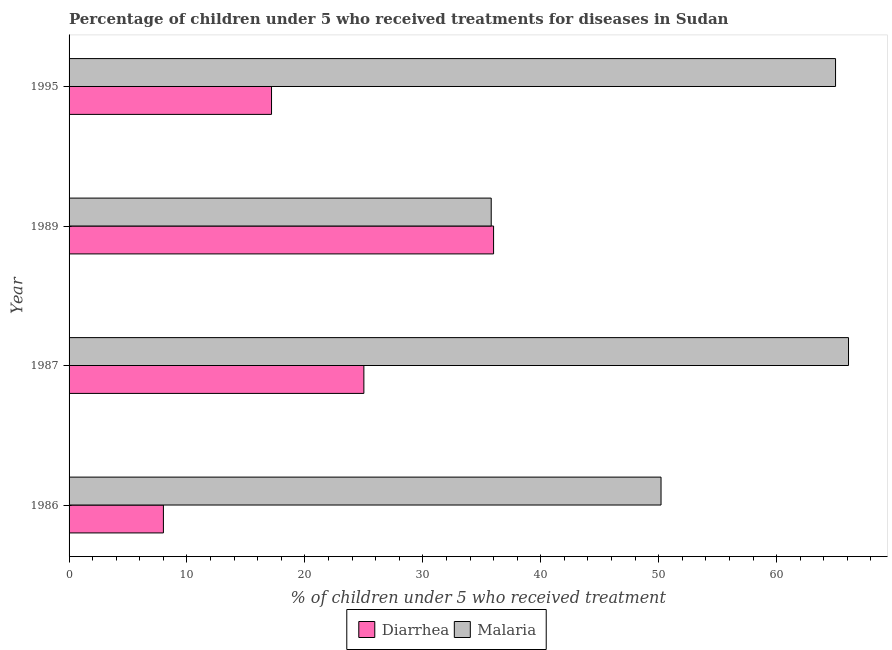How many different coloured bars are there?
Give a very brief answer. 2. What is the label of the 2nd group of bars from the top?
Your response must be concise. 1989. In which year was the percentage of children who received treatment for malaria maximum?
Offer a terse response. 1987. In which year was the percentage of children who received treatment for malaria minimum?
Make the answer very short. 1989. What is the total percentage of children who received treatment for diarrhoea in the graph?
Keep it short and to the point. 86.17. What is the difference between the percentage of children who received treatment for diarrhoea in 1989 and that in 1995?
Give a very brief answer. 18.83. What is the difference between the percentage of children who received treatment for diarrhoea in 1987 and the percentage of children who received treatment for malaria in 1989?
Make the answer very short. -10.8. What is the average percentage of children who received treatment for diarrhoea per year?
Provide a succinct answer. 21.54. In the year 1995, what is the difference between the percentage of children who received treatment for diarrhoea and percentage of children who received treatment for malaria?
Provide a short and direct response. -47.83. In how many years, is the percentage of children who received treatment for diarrhoea greater than 56 %?
Make the answer very short. 0. What is the ratio of the percentage of children who received treatment for diarrhoea in 1986 to that in 1989?
Provide a succinct answer. 0.22. Is the percentage of children who received treatment for malaria in 1989 less than that in 1995?
Make the answer very short. Yes. What is the difference between the highest and the second highest percentage of children who received treatment for malaria?
Ensure brevity in your answer.  1.1. What is the difference between the highest and the lowest percentage of children who received treatment for malaria?
Your response must be concise. 30.3. Is the sum of the percentage of children who received treatment for diarrhoea in 1986 and 1995 greater than the maximum percentage of children who received treatment for malaria across all years?
Offer a terse response. No. What does the 1st bar from the top in 1989 represents?
Ensure brevity in your answer.  Malaria. What does the 2nd bar from the bottom in 1986 represents?
Provide a short and direct response. Malaria. How many bars are there?
Give a very brief answer. 8. What is the difference between two consecutive major ticks on the X-axis?
Your answer should be compact. 10. Does the graph contain any zero values?
Offer a very short reply. No. What is the title of the graph?
Your answer should be compact. Percentage of children under 5 who received treatments for diseases in Sudan. What is the label or title of the X-axis?
Make the answer very short. % of children under 5 who received treatment. What is the label or title of the Y-axis?
Offer a terse response. Year. What is the % of children under 5 who received treatment of Malaria in 1986?
Provide a short and direct response. 50.2. What is the % of children under 5 who received treatment of Diarrhea in 1987?
Your answer should be compact. 25. What is the % of children under 5 who received treatment in Malaria in 1987?
Offer a terse response. 66.1. What is the % of children under 5 who received treatment of Malaria in 1989?
Your answer should be compact. 35.8. What is the % of children under 5 who received treatment in Diarrhea in 1995?
Ensure brevity in your answer.  17.17. Across all years, what is the maximum % of children under 5 who received treatment of Diarrhea?
Offer a terse response. 36. Across all years, what is the maximum % of children under 5 who received treatment in Malaria?
Give a very brief answer. 66.1. Across all years, what is the minimum % of children under 5 who received treatment in Malaria?
Provide a short and direct response. 35.8. What is the total % of children under 5 who received treatment in Diarrhea in the graph?
Keep it short and to the point. 86.17. What is the total % of children under 5 who received treatment in Malaria in the graph?
Your answer should be compact. 217.1. What is the difference between the % of children under 5 who received treatment in Malaria in 1986 and that in 1987?
Give a very brief answer. -15.9. What is the difference between the % of children under 5 who received treatment in Diarrhea in 1986 and that in 1995?
Offer a terse response. -9.17. What is the difference between the % of children under 5 who received treatment of Malaria in 1986 and that in 1995?
Give a very brief answer. -14.8. What is the difference between the % of children under 5 who received treatment of Diarrhea in 1987 and that in 1989?
Provide a succinct answer. -11. What is the difference between the % of children under 5 who received treatment of Malaria in 1987 and that in 1989?
Your answer should be compact. 30.3. What is the difference between the % of children under 5 who received treatment of Diarrhea in 1987 and that in 1995?
Your answer should be very brief. 7.83. What is the difference between the % of children under 5 who received treatment of Diarrhea in 1989 and that in 1995?
Provide a short and direct response. 18.83. What is the difference between the % of children under 5 who received treatment of Malaria in 1989 and that in 1995?
Provide a short and direct response. -29.2. What is the difference between the % of children under 5 who received treatment of Diarrhea in 1986 and the % of children under 5 who received treatment of Malaria in 1987?
Provide a short and direct response. -58.1. What is the difference between the % of children under 5 who received treatment of Diarrhea in 1986 and the % of children under 5 who received treatment of Malaria in 1989?
Make the answer very short. -27.8. What is the difference between the % of children under 5 who received treatment in Diarrhea in 1986 and the % of children under 5 who received treatment in Malaria in 1995?
Keep it short and to the point. -57. What is the difference between the % of children under 5 who received treatment of Diarrhea in 1987 and the % of children under 5 who received treatment of Malaria in 1989?
Offer a terse response. -10.8. What is the difference between the % of children under 5 who received treatment of Diarrhea in 1987 and the % of children under 5 who received treatment of Malaria in 1995?
Give a very brief answer. -40. What is the difference between the % of children under 5 who received treatment of Diarrhea in 1989 and the % of children under 5 who received treatment of Malaria in 1995?
Offer a very short reply. -29. What is the average % of children under 5 who received treatment in Diarrhea per year?
Provide a succinct answer. 21.54. What is the average % of children under 5 who received treatment of Malaria per year?
Your answer should be very brief. 54.27. In the year 1986, what is the difference between the % of children under 5 who received treatment of Diarrhea and % of children under 5 who received treatment of Malaria?
Ensure brevity in your answer.  -42.2. In the year 1987, what is the difference between the % of children under 5 who received treatment in Diarrhea and % of children under 5 who received treatment in Malaria?
Your response must be concise. -41.1. In the year 1989, what is the difference between the % of children under 5 who received treatment in Diarrhea and % of children under 5 who received treatment in Malaria?
Ensure brevity in your answer.  0.2. In the year 1995, what is the difference between the % of children under 5 who received treatment in Diarrhea and % of children under 5 who received treatment in Malaria?
Your answer should be very brief. -47.83. What is the ratio of the % of children under 5 who received treatment in Diarrhea in 1986 to that in 1987?
Give a very brief answer. 0.32. What is the ratio of the % of children under 5 who received treatment in Malaria in 1986 to that in 1987?
Ensure brevity in your answer.  0.76. What is the ratio of the % of children under 5 who received treatment of Diarrhea in 1986 to that in 1989?
Your response must be concise. 0.22. What is the ratio of the % of children under 5 who received treatment in Malaria in 1986 to that in 1989?
Offer a very short reply. 1.4. What is the ratio of the % of children under 5 who received treatment of Diarrhea in 1986 to that in 1995?
Offer a very short reply. 0.47. What is the ratio of the % of children under 5 who received treatment of Malaria in 1986 to that in 1995?
Provide a succinct answer. 0.77. What is the ratio of the % of children under 5 who received treatment of Diarrhea in 1987 to that in 1989?
Your answer should be very brief. 0.69. What is the ratio of the % of children under 5 who received treatment of Malaria in 1987 to that in 1989?
Offer a very short reply. 1.85. What is the ratio of the % of children under 5 who received treatment in Diarrhea in 1987 to that in 1995?
Make the answer very short. 1.46. What is the ratio of the % of children under 5 who received treatment of Malaria in 1987 to that in 1995?
Make the answer very short. 1.02. What is the ratio of the % of children under 5 who received treatment in Diarrhea in 1989 to that in 1995?
Offer a very short reply. 2.1. What is the ratio of the % of children under 5 who received treatment in Malaria in 1989 to that in 1995?
Offer a terse response. 0.55. What is the difference between the highest and the second highest % of children under 5 who received treatment in Diarrhea?
Give a very brief answer. 11. What is the difference between the highest and the lowest % of children under 5 who received treatment in Diarrhea?
Provide a succinct answer. 28. What is the difference between the highest and the lowest % of children under 5 who received treatment of Malaria?
Provide a succinct answer. 30.3. 